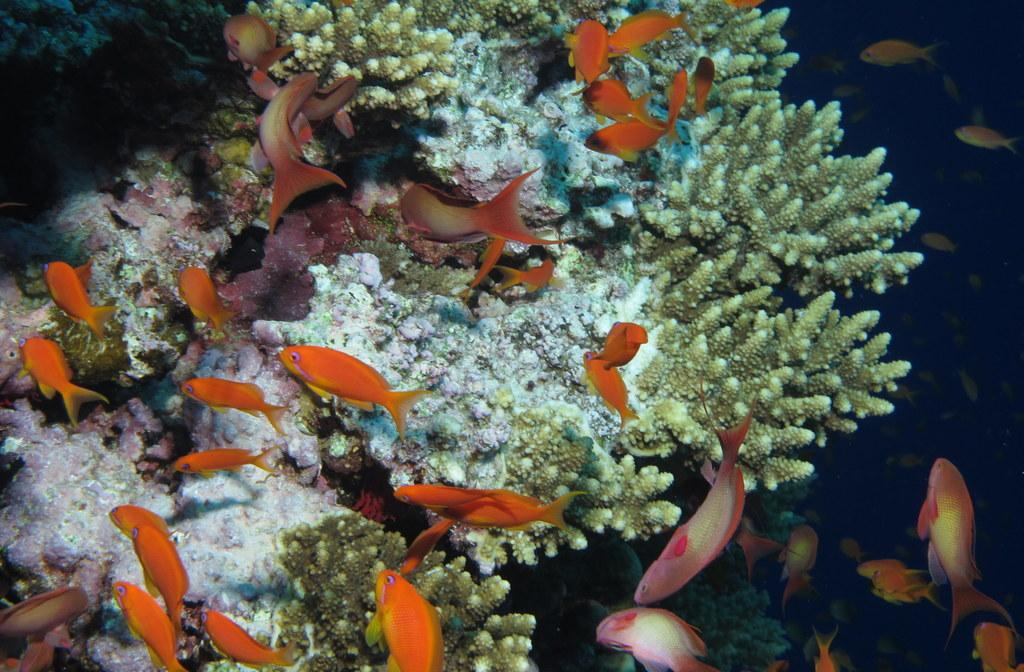What type of environment is shown in the image? The image depicts deep water. Are there any plants visible in the image? Yes, there is a water plant in the image. What type of animals can be seen in the image? There are orange-colored fishes in the image. Where is the clock located in the image? There is no clock present in the image. What type of mailbox can be seen near the water plant? There is no mailbox present in the image. 